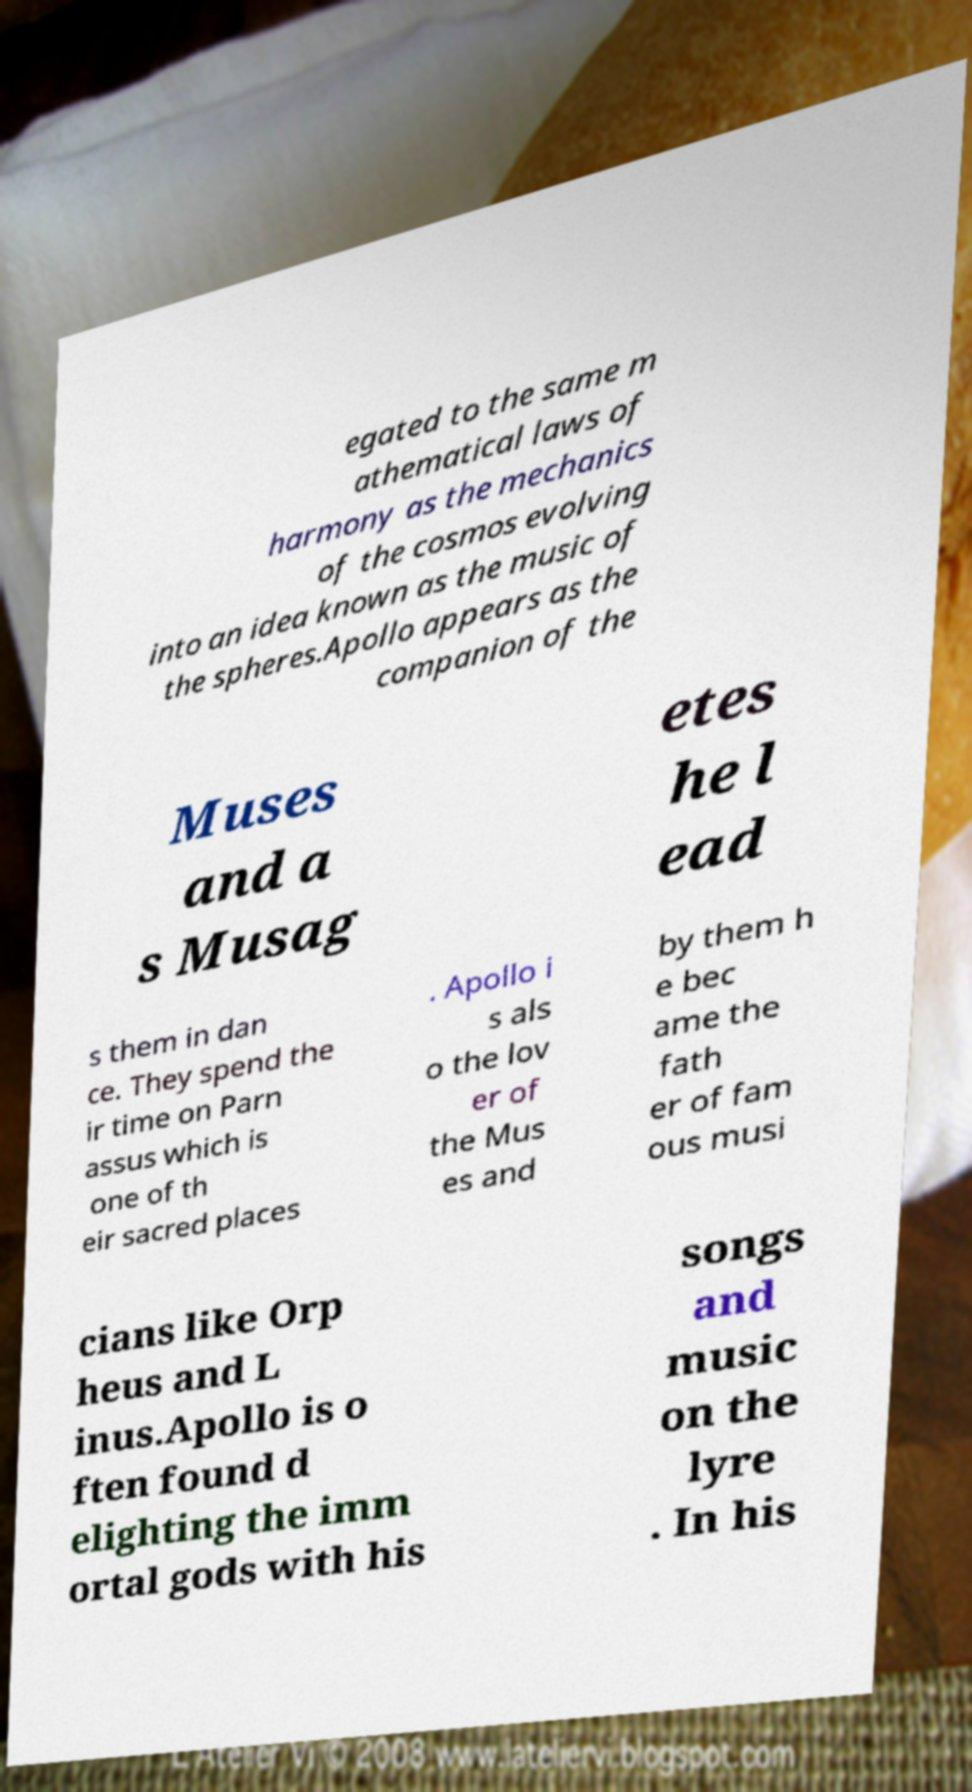What messages or text are displayed in this image? I need them in a readable, typed format. egated to the same m athematical laws of harmony as the mechanics of the cosmos evolving into an idea known as the music of the spheres.Apollo appears as the companion of the Muses and a s Musag etes he l ead s them in dan ce. They spend the ir time on Parn assus which is one of th eir sacred places . Apollo i s als o the lov er of the Mus es and by them h e bec ame the fath er of fam ous musi cians like Orp heus and L inus.Apollo is o ften found d elighting the imm ortal gods with his songs and music on the lyre . In his 